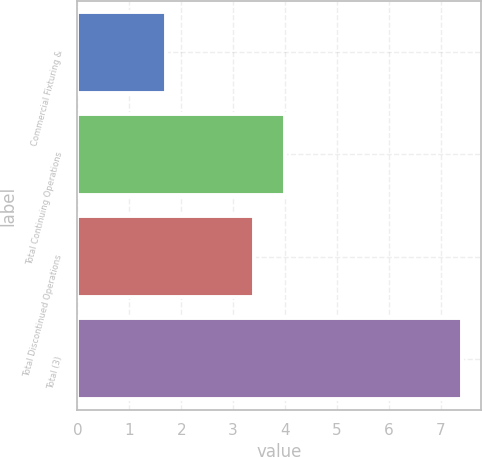<chart> <loc_0><loc_0><loc_500><loc_500><bar_chart><fcel>Commercial Fixturing &<fcel>Total Continuing Operations<fcel>Total Discontinued Operations<fcel>Total (3)<nl><fcel>1.7<fcel>4<fcel>3.4<fcel>7.4<nl></chart> 